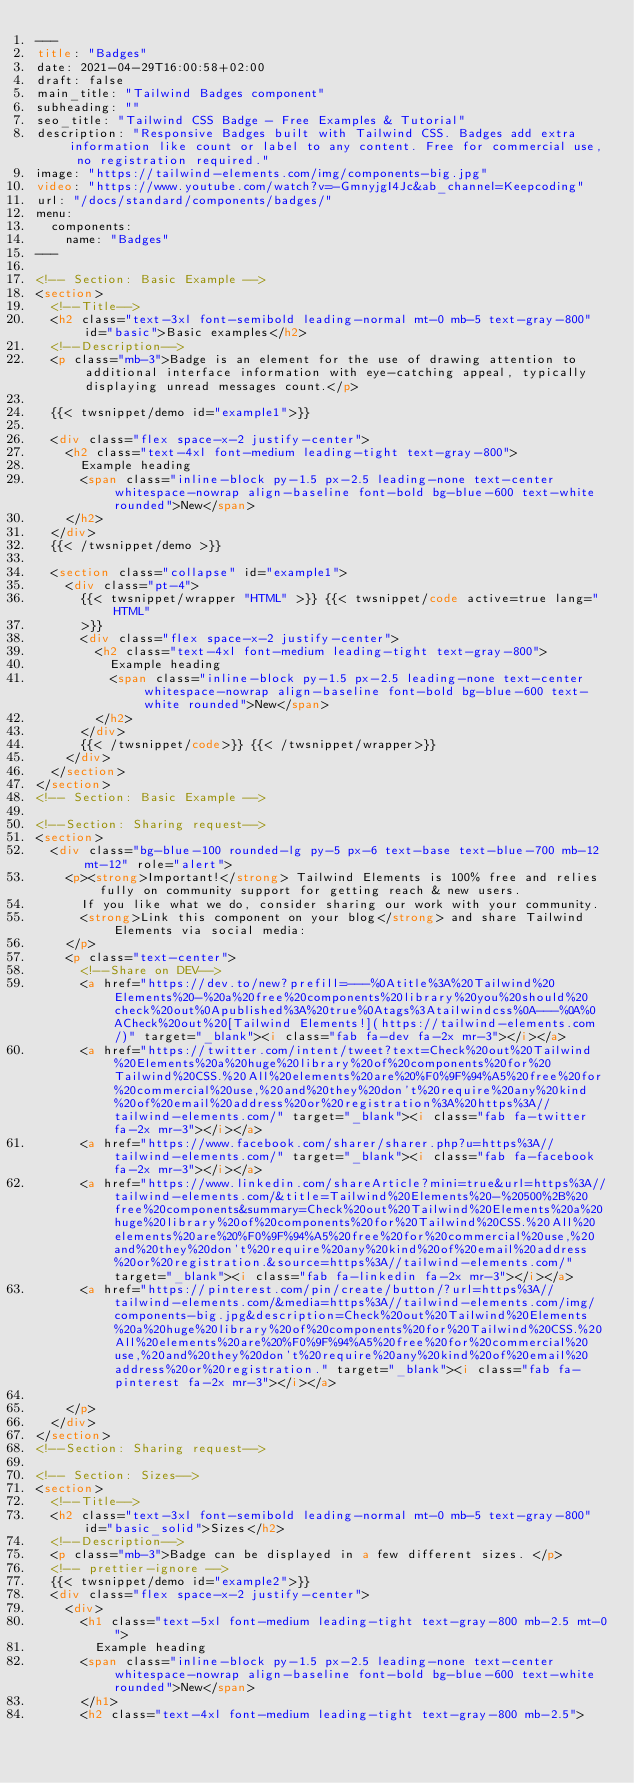<code> <loc_0><loc_0><loc_500><loc_500><_HTML_>---
title: "Badges"
date: 2021-04-29T16:00:58+02:00
draft: false
main_title: "Tailwind Badges component"
subheading: ""
seo_title: "Tailwind CSS Badge - Free Examples & Tutorial"
description: "Responsive Badges built with Tailwind CSS. Badges add extra information like count or label to any content. Free for commercial use, no registration required."
image: "https://tailwind-elements.com/img/components-big.jpg"
video: "https://www.youtube.com/watch?v=-GmnyjgI4Jc&ab_channel=Keepcoding"
url: "/docs/standard/components/badges/"
menu:
  components:
    name: "Badges"
---

<!-- Section: Basic Example -->
<section>
  <!--Title-->
  <h2 class="text-3xl font-semibold leading-normal mt-0 mb-5 text-gray-800" id="basic">Basic examples</h2>
  <!--Description-->
  <p class="mb-3">Badge is an element for the use of drawing attention to additional interface information with eye-catching appeal, typically displaying unread messages count.</p>

  {{< twsnippet/demo id="example1">}}

  <div class="flex space-x-2 justify-center">
    <h2 class="text-4xl font-medium leading-tight text-gray-800">
      Example heading
      <span class="inline-block py-1.5 px-2.5 leading-none text-center whitespace-nowrap align-baseline font-bold bg-blue-600 text-white rounded">New</span>
    </h2>
  </div>
  {{< /twsnippet/demo >}}

  <section class="collapse" id="example1">
    <div class="pt-4">
      {{< twsnippet/wrapper "HTML" >}} {{< twsnippet/code active=true lang="HTML"
      >}}
      <div class="flex space-x-2 justify-center">
        <h2 class="text-4xl font-medium leading-tight text-gray-800">
          Example heading
          <span class="inline-block py-1.5 px-2.5 leading-none text-center whitespace-nowrap align-baseline font-bold bg-blue-600 text-white rounded">New</span>
        </h2>
      </div>
      {{< /twsnippet/code>}} {{< /twsnippet/wrapper>}}
    </div>
  </section>
</section>
<!-- Section: Basic Example -->

<!--Section: Sharing request-->
<section>
  <div class="bg-blue-100 rounded-lg py-5 px-6 text-base text-blue-700 mb-12 mt-12" role="alert">
    <p><strong>Important!</strong> Tailwind Elements is 100% free and relies fully on community support for getting reach & new users. 
      If you like what we do, consider sharing our work with your community. 
      <strong>Link this component on your blog</strong> and share Tailwind Elements via social media: 
    </p>
    <p class="text-center">
      <!--Share on DEV-->
      <a href="https://dev.to/new?prefill=---%0Atitle%3A%20Tailwind%20Elements%20-%20a%20free%20components%20library%20you%20should%20check%20out%0Apublished%3A%20true%0Atags%3Atailwindcss%0A---%0A%0ACheck%20out%20[Tailwind Elements!](https://tailwind-elements.com/)" target="_blank"><i class="fab fa-dev fa-2x mr-3"></i></a>
      <a href="https://twitter.com/intent/tweet?text=Check%20out%20Tailwind%20Elements%20a%20huge%20library%20of%20components%20for%20Tailwind%20CSS.%20All%20elements%20are%20%F0%9F%94%A5%20free%20for%20commercial%20use,%20and%20they%20don't%20require%20any%20kind%20of%20email%20address%20or%20registration%3A%20https%3A//tailwind-elements.com/" target="_blank"><i class="fab fa-twitter fa-2x mr-3"></i></a>
      <a href="https://www.facebook.com/sharer/sharer.php?u=https%3A//tailwind-elements.com/" target="_blank"><i class="fab fa-facebook fa-2x mr-3"></i></a>
      <a href="https://www.linkedin.com/shareArticle?mini=true&url=https%3A//tailwind-elements.com/&title=Tailwind%20Elements%20-%20500%2B%20free%20components&summary=Check%20out%20Tailwind%20Elements%20a%20huge%20library%20of%20components%20for%20Tailwind%20CSS.%20All%20elements%20are%20%F0%9F%94%A5%20free%20for%20commercial%20use,%20and%20they%20don't%20require%20any%20kind%20of%20email%20address%20or%20registration.&source=https%3A//tailwind-elements.com/" target="_blank"><i class="fab fa-linkedin fa-2x mr-3"></i></a>
      <a href="https://pinterest.com/pin/create/button/?url=https%3A//tailwind-elements.com/&media=https%3A//tailwind-elements.com/img/components-big.jpg&description=Check%20out%20Tailwind%20Elements%20a%20huge%20library%20of%20components%20for%20Tailwind%20CSS.%20All%20elements%20are%20%F0%9F%94%A5%20free%20for%20commercial%20use,%20and%20they%20don't%20require%20any%20kind%20of%20email%20address%20or%20registration." target="_blank"><i class="fab fa-pinterest fa-2x mr-3"></i></a>

    </p>
  </div>
</section>
<!--Section: Sharing request-->

<!-- Section: Sizes-->
<section>   
  <!--Title-->
  <h2 class="text-3xl font-semibold leading-normal mt-0 mb-5 text-gray-800" id="basic_solid">Sizes</h2>
  <!--Description-->
  <p class="mb-3">Badge can be displayed in a few different sizes. </p>
  <!-- prettier-ignore -->
  {{< twsnippet/demo id="example2">}}
  <div class="flex space-x-2 justify-center">
    <div>
      <h1 class="text-5xl font-medium leading-tight text-gray-800 mb-2.5 mt-0">
        Example heading
      <span class="inline-block py-1.5 px-2.5 leading-none text-center whitespace-nowrap align-baseline font-bold bg-blue-600 text-white rounded">New</span>
      </h1>
      <h2 class="text-4xl font-medium leading-tight text-gray-800 mb-2.5"></code> 